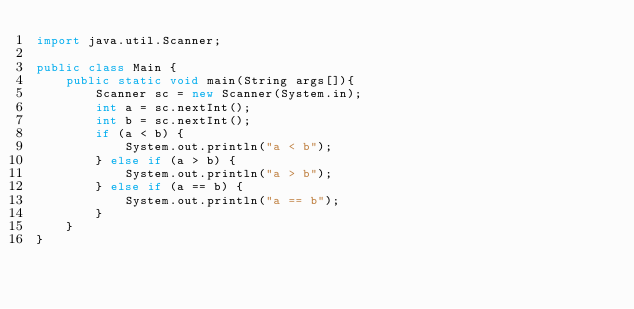<code> <loc_0><loc_0><loc_500><loc_500><_Java_>import java.util.Scanner;

public class Main {
	public static void main(String args[]){
		Scanner sc = new Scanner(System.in);
		int a = sc.nextInt();
		int b = sc.nextInt();
		if (a < b) {
			System.out.println("a < b");
		} else if (a > b) {
			System.out.println("a > b");
		} else if (a == b) {
			System.out.println("a == b");
		}
	}
}
</code> 